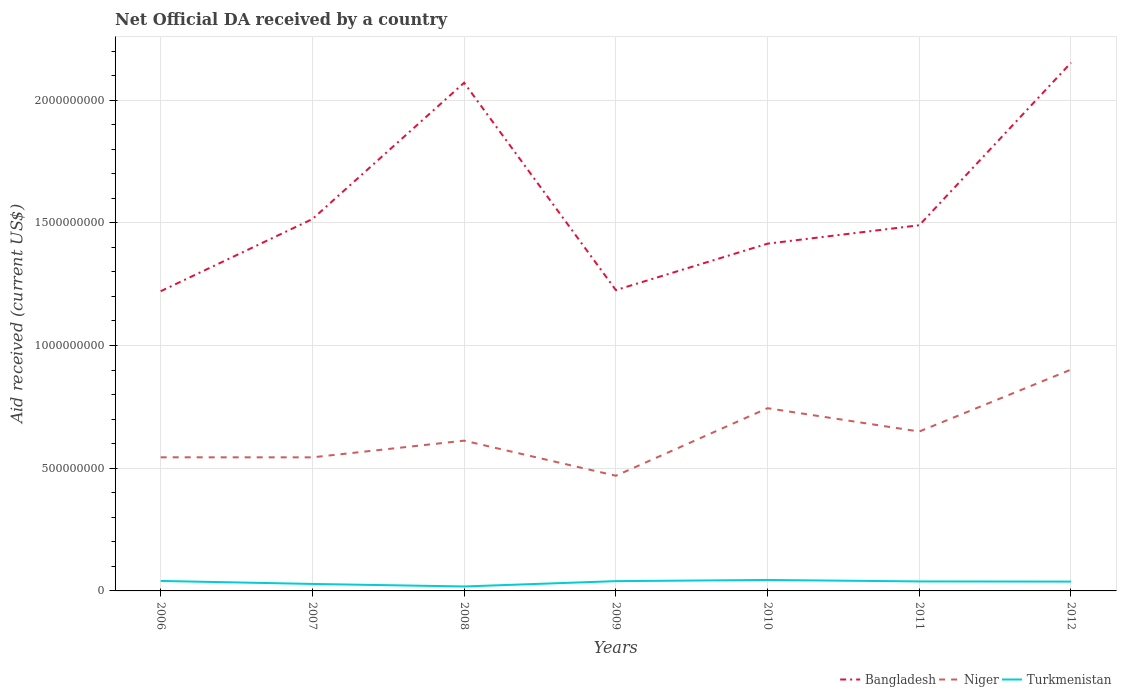Is the number of lines equal to the number of legend labels?
Ensure brevity in your answer.  Yes. Across all years, what is the maximum net official development assistance aid received in Bangladesh?
Offer a terse response. 1.22e+09. In which year was the net official development assistance aid received in Turkmenistan maximum?
Ensure brevity in your answer.  2008. What is the total net official development assistance aid received in Turkmenistan in the graph?
Your answer should be very brief. 5.97e+06. What is the difference between the highest and the second highest net official development assistance aid received in Turkmenistan?
Make the answer very short. 2.65e+07. Is the net official development assistance aid received in Turkmenistan strictly greater than the net official development assistance aid received in Niger over the years?
Offer a terse response. Yes. How many lines are there?
Your response must be concise. 3. What is the difference between two consecutive major ticks on the Y-axis?
Offer a very short reply. 5.00e+08. What is the title of the graph?
Provide a succinct answer. Net Official DA received by a country. Does "Dominica" appear as one of the legend labels in the graph?
Offer a very short reply. No. What is the label or title of the Y-axis?
Your response must be concise. Aid received (current US$). What is the Aid received (current US$) of Bangladesh in 2006?
Provide a succinct answer. 1.22e+09. What is the Aid received (current US$) in Niger in 2006?
Give a very brief answer. 5.44e+08. What is the Aid received (current US$) of Turkmenistan in 2006?
Keep it short and to the point. 4.07e+07. What is the Aid received (current US$) of Bangladesh in 2007?
Your response must be concise. 1.52e+09. What is the Aid received (current US$) of Niger in 2007?
Offer a terse response. 5.44e+08. What is the Aid received (current US$) in Turkmenistan in 2007?
Provide a short and direct response. 2.85e+07. What is the Aid received (current US$) of Bangladesh in 2008?
Keep it short and to the point. 2.07e+09. What is the Aid received (current US$) of Niger in 2008?
Offer a terse response. 6.12e+08. What is the Aid received (current US$) in Turkmenistan in 2008?
Your response must be concise. 1.81e+07. What is the Aid received (current US$) in Bangladesh in 2009?
Keep it short and to the point. 1.23e+09. What is the Aid received (current US$) in Niger in 2009?
Your answer should be compact. 4.69e+08. What is the Aid received (current US$) of Turkmenistan in 2009?
Give a very brief answer. 3.98e+07. What is the Aid received (current US$) in Bangladesh in 2010?
Provide a short and direct response. 1.41e+09. What is the Aid received (current US$) of Niger in 2010?
Provide a succinct answer. 7.45e+08. What is the Aid received (current US$) in Turkmenistan in 2010?
Make the answer very short. 4.46e+07. What is the Aid received (current US$) in Bangladesh in 2011?
Keep it short and to the point. 1.49e+09. What is the Aid received (current US$) in Niger in 2011?
Your response must be concise. 6.50e+08. What is the Aid received (current US$) in Turkmenistan in 2011?
Keep it short and to the point. 3.87e+07. What is the Aid received (current US$) in Bangladesh in 2012?
Provide a succinct answer. 2.15e+09. What is the Aid received (current US$) in Niger in 2012?
Give a very brief answer. 9.02e+08. What is the Aid received (current US$) of Turkmenistan in 2012?
Keep it short and to the point. 3.80e+07. Across all years, what is the maximum Aid received (current US$) of Bangladesh?
Your answer should be very brief. 2.15e+09. Across all years, what is the maximum Aid received (current US$) in Niger?
Your answer should be very brief. 9.02e+08. Across all years, what is the maximum Aid received (current US$) in Turkmenistan?
Your answer should be compact. 4.46e+07. Across all years, what is the minimum Aid received (current US$) of Bangladesh?
Your response must be concise. 1.22e+09. Across all years, what is the minimum Aid received (current US$) of Niger?
Provide a succinct answer. 4.69e+08. Across all years, what is the minimum Aid received (current US$) of Turkmenistan?
Offer a very short reply. 1.81e+07. What is the total Aid received (current US$) of Bangladesh in the graph?
Your answer should be very brief. 1.11e+1. What is the total Aid received (current US$) in Niger in the graph?
Ensure brevity in your answer.  4.47e+09. What is the total Aid received (current US$) in Turkmenistan in the graph?
Your answer should be compact. 2.49e+08. What is the difference between the Aid received (current US$) of Bangladesh in 2006 and that in 2007?
Your answer should be compact. -2.94e+08. What is the difference between the Aid received (current US$) of Niger in 2006 and that in 2007?
Ensure brevity in your answer.  1.10e+05. What is the difference between the Aid received (current US$) in Turkmenistan in 2006 and that in 2007?
Your answer should be very brief. 1.22e+07. What is the difference between the Aid received (current US$) in Bangladesh in 2006 and that in 2008?
Offer a very short reply. -8.49e+08. What is the difference between the Aid received (current US$) in Niger in 2006 and that in 2008?
Offer a terse response. -6.79e+07. What is the difference between the Aid received (current US$) of Turkmenistan in 2006 and that in 2008?
Provide a short and direct response. 2.26e+07. What is the difference between the Aid received (current US$) of Bangladesh in 2006 and that in 2009?
Offer a very short reply. -4.64e+06. What is the difference between the Aid received (current US$) of Niger in 2006 and that in 2009?
Make the answer very short. 7.51e+07. What is the difference between the Aid received (current US$) of Turkmenistan in 2006 and that in 2009?
Make the answer very short. 8.70e+05. What is the difference between the Aid received (current US$) in Bangladesh in 2006 and that in 2010?
Give a very brief answer. -1.94e+08. What is the difference between the Aid received (current US$) of Niger in 2006 and that in 2010?
Offer a very short reply. -2.00e+08. What is the difference between the Aid received (current US$) of Turkmenistan in 2006 and that in 2010?
Give a very brief answer. -3.94e+06. What is the difference between the Aid received (current US$) in Bangladesh in 2006 and that in 2011?
Offer a terse response. -2.69e+08. What is the difference between the Aid received (current US$) in Niger in 2006 and that in 2011?
Keep it short and to the point. -1.05e+08. What is the difference between the Aid received (current US$) in Turkmenistan in 2006 and that in 2011?
Ensure brevity in your answer.  2.03e+06. What is the difference between the Aid received (current US$) in Bangladesh in 2006 and that in 2012?
Keep it short and to the point. -9.31e+08. What is the difference between the Aid received (current US$) in Niger in 2006 and that in 2012?
Your answer should be very brief. -3.57e+08. What is the difference between the Aid received (current US$) of Turkmenistan in 2006 and that in 2012?
Offer a very short reply. 2.68e+06. What is the difference between the Aid received (current US$) of Bangladesh in 2007 and that in 2008?
Ensure brevity in your answer.  -5.55e+08. What is the difference between the Aid received (current US$) in Niger in 2007 and that in 2008?
Make the answer very short. -6.80e+07. What is the difference between the Aid received (current US$) of Turkmenistan in 2007 and that in 2008?
Your answer should be very brief. 1.04e+07. What is the difference between the Aid received (current US$) of Bangladesh in 2007 and that in 2009?
Keep it short and to the point. 2.89e+08. What is the difference between the Aid received (current US$) of Niger in 2007 and that in 2009?
Your response must be concise. 7.50e+07. What is the difference between the Aid received (current US$) of Turkmenistan in 2007 and that in 2009?
Give a very brief answer. -1.14e+07. What is the difference between the Aid received (current US$) in Bangladesh in 2007 and that in 2010?
Make the answer very short. 1.00e+08. What is the difference between the Aid received (current US$) in Niger in 2007 and that in 2010?
Give a very brief answer. -2.00e+08. What is the difference between the Aid received (current US$) of Turkmenistan in 2007 and that in 2010?
Provide a short and direct response. -1.62e+07. What is the difference between the Aid received (current US$) of Bangladesh in 2007 and that in 2011?
Provide a short and direct response. 2.52e+07. What is the difference between the Aid received (current US$) in Niger in 2007 and that in 2011?
Offer a terse response. -1.05e+08. What is the difference between the Aid received (current US$) of Turkmenistan in 2007 and that in 2011?
Keep it short and to the point. -1.02e+07. What is the difference between the Aid received (current US$) of Bangladesh in 2007 and that in 2012?
Provide a succinct answer. -6.37e+08. What is the difference between the Aid received (current US$) of Niger in 2007 and that in 2012?
Your answer should be very brief. -3.58e+08. What is the difference between the Aid received (current US$) of Turkmenistan in 2007 and that in 2012?
Make the answer very short. -9.55e+06. What is the difference between the Aid received (current US$) of Bangladesh in 2008 and that in 2009?
Your answer should be very brief. 8.45e+08. What is the difference between the Aid received (current US$) in Niger in 2008 and that in 2009?
Keep it short and to the point. 1.43e+08. What is the difference between the Aid received (current US$) in Turkmenistan in 2008 and that in 2009?
Provide a succinct answer. -2.17e+07. What is the difference between the Aid received (current US$) in Bangladesh in 2008 and that in 2010?
Keep it short and to the point. 6.56e+08. What is the difference between the Aid received (current US$) of Niger in 2008 and that in 2010?
Offer a very short reply. -1.32e+08. What is the difference between the Aid received (current US$) in Turkmenistan in 2008 and that in 2010?
Ensure brevity in your answer.  -2.65e+07. What is the difference between the Aid received (current US$) in Bangladesh in 2008 and that in 2011?
Offer a very short reply. 5.81e+08. What is the difference between the Aid received (current US$) of Niger in 2008 and that in 2011?
Your answer should be compact. -3.72e+07. What is the difference between the Aid received (current US$) of Turkmenistan in 2008 and that in 2011?
Offer a very short reply. -2.06e+07. What is the difference between the Aid received (current US$) of Bangladesh in 2008 and that in 2012?
Make the answer very short. -8.15e+07. What is the difference between the Aid received (current US$) in Niger in 2008 and that in 2012?
Keep it short and to the point. -2.90e+08. What is the difference between the Aid received (current US$) of Turkmenistan in 2008 and that in 2012?
Offer a very short reply. -1.99e+07. What is the difference between the Aid received (current US$) in Bangladesh in 2009 and that in 2010?
Your answer should be compact. -1.89e+08. What is the difference between the Aid received (current US$) of Niger in 2009 and that in 2010?
Give a very brief answer. -2.75e+08. What is the difference between the Aid received (current US$) in Turkmenistan in 2009 and that in 2010?
Keep it short and to the point. -4.81e+06. What is the difference between the Aid received (current US$) in Bangladesh in 2009 and that in 2011?
Make the answer very short. -2.64e+08. What is the difference between the Aid received (current US$) in Niger in 2009 and that in 2011?
Offer a very short reply. -1.80e+08. What is the difference between the Aid received (current US$) of Turkmenistan in 2009 and that in 2011?
Provide a short and direct response. 1.16e+06. What is the difference between the Aid received (current US$) of Bangladesh in 2009 and that in 2012?
Offer a very short reply. -9.26e+08. What is the difference between the Aid received (current US$) of Niger in 2009 and that in 2012?
Your answer should be compact. -4.33e+08. What is the difference between the Aid received (current US$) in Turkmenistan in 2009 and that in 2012?
Make the answer very short. 1.81e+06. What is the difference between the Aid received (current US$) in Bangladesh in 2010 and that in 2011?
Provide a short and direct response. -7.51e+07. What is the difference between the Aid received (current US$) in Niger in 2010 and that in 2011?
Offer a terse response. 9.50e+07. What is the difference between the Aid received (current US$) in Turkmenistan in 2010 and that in 2011?
Provide a short and direct response. 5.97e+06. What is the difference between the Aid received (current US$) of Bangladesh in 2010 and that in 2012?
Make the answer very short. -7.37e+08. What is the difference between the Aid received (current US$) of Niger in 2010 and that in 2012?
Ensure brevity in your answer.  -1.57e+08. What is the difference between the Aid received (current US$) of Turkmenistan in 2010 and that in 2012?
Keep it short and to the point. 6.62e+06. What is the difference between the Aid received (current US$) in Bangladesh in 2011 and that in 2012?
Your response must be concise. -6.62e+08. What is the difference between the Aid received (current US$) of Niger in 2011 and that in 2012?
Offer a very short reply. -2.52e+08. What is the difference between the Aid received (current US$) of Turkmenistan in 2011 and that in 2012?
Make the answer very short. 6.50e+05. What is the difference between the Aid received (current US$) in Bangladesh in 2006 and the Aid received (current US$) in Niger in 2007?
Provide a succinct answer. 6.77e+08. What is the difference between the Aid received (current US$) of Bangladesh in 2006 and the Aid received (current US$) of Turkmenistan in 2007?
Make the answer very short. 1.19e+09. What is the difference between the Aid received (current US$) in Niger in 2006 and the Aid received (current US$) in Turkmenistan in 2007?
Ensure brevity in your answer.  5.16e+08. What is the difference between the Aid received (current US$) of Bangladesh in 2006 and the Aid received (current US$) of Niger in 2008?
Provide a succinct answer. 6.09e+08. What is the difference between the Aid received (current US$) of Bangladesh in 2006 and the Aid received (current US$) of Turkmenistan in 2008?
Your answer should be compact. 1.20e+09. What is the difference between the Aid received (current US$) of Niger in 2006 and the Aid received (current US$) of Turkmenistan in 2008?
Your response must be concise. 5.26e+08. What is the difference between the Aid received (current US$) in Bangladesh in 2006 and the Aid received (current US$) in Niger in 2009?
Provide a short and direct response. 7.52e+08. What is the difference between the Aid received (current US$) of Bangladesh in 2006 and the Aid received (current US$) of Turkmenistan in 2009?
Make the answer very short. 1.18e+09. What is the difference between the Aid received (current US$) of Niger in 2006 and the Aid received (current US$) of Turkmenistan in 2009?
Provide a short and direct response. 5.05e+08. What is the difference between the Aid received (current US$) of Bangladesh in 2006 and the Aid received (current US$) of Niger in 2010?
Provide a short and direct response. 4.77e+08. What is the difference between the Aid received (current US$) in Bangladesh in 2006 and the Aid received (current US$) in Turkmenistan in 2010?
Keep it short and to the point. 1.18e+09. What is the difference between the Aid received (current US$) of Niger in 2006 and the Aid received (current US$) of Turkmenistan in 2010?
Your response must be concise. 5.00e+08. What is the difference between the Aid received (current US$) of Bangladesh in 2006 and the Aid received (current US$) of Niger in 2011?
Offer a very short reply. 5.72e+08. What is the difference between the Aid received (current US$) in Bangladesh in 2006 and the Aid received (current US$) in Turkmenistan in 2011?
Your answer should be compact. 1.18e+09. What is the difference between the Aid received (current US$) in Niger in 2006 and the Aid received (current US$) in Turkmenistan in 2011?
Provide a short and direct response. 5.06e+08. What is the difference between the Aid received (current US$) in Bangladesh in 2006 and the Aid received (current US$) in Niger in 2012?
Your response must be concise. 3.19e+08. What is the difference between the Aid received (current US$) of Bangladesh in 2006 and the Aid received (current US$) of Turkmenistan in 2012?
Your answer should be compact. 1.18e+09. What is the difference between the Aid received (current US$) in Niger in 2006 and the Aid received (current US$) in Turkmenistan in 2012?
Your answer should be compact. 5.06e+08. What is the difference between the Aid received (current US$) of Bangladesh in 2007 and the Aid received (current US$) of Niger in 2008?
Your answer should be compact. 9.03e+08. What is the difference between the Aid received (current US$) of Bangladesh in 2007 and the Aid received (current US$) of Turkmenistan in 2008?
Your answer should be compact. 1.50e+09. What is the difference between the Aid received (current US$) in Niger in 2007 and the Aid received (current US$) in Turkmenistan in 2008?
Give a very brief answer. 5.26e+08. What is the difference between the Aid received (current US$) of Bangladesh in 2007 and the Aid received (current US$) of Niger in 2009?
Keep it short and to the point. 1.05e+09. What is the difference between the Aid received (current US$) in Bangladesh in 2007 and the Aid received (current US$) in Turkmenistan in 2009?
Offer a terse response. 1.48e+09. What is the difference between the Aid received (current US$) in Niger in 2007 and the Aid received (current US$) in Turkmenistan in 2009?
Keep it short and to the point. 5.04e+08. What is the difference between the Aid received (current US$) in Bangladesh in 2007 and the Aid received (current US$) in Niger in 2010?
Your response must be concise. 7.71e+08. What is the difference between the Aid received (current US$) in Bangladesh in 2007 and the Aid received (current US$) in Turkmenistan in 2010?
Provide a short and direct response. 1.47e+09. What is the difference between the Aid received (current US$) in Niger in 2007 and the Aid received (current US$) in Turkmenistan in 2010?
Keep it short and to the point. 5.00e+08. What is the difference between the Aid received (current US$) of Bangladesh in 2007 and the Aid received (current US$) of Niger in 2011?
Ensure brevity in your answer.  8.66e+08. What is the difference between the Aid received (current US$) in Bangladesh in 2007 and the Aid received (current US$) in Turkmenistan in 2011?
Provide a succinct answer. 1.48e+09. What is the difference between the Aid received (current US$) of Niger in 2007 and the Aid received (current US$) of Turkmenistan in 2011?
Keep it short and to the point. 5.06e+08. What is the difference between the Aid received (current US$) in Bangladesh in 2007 and the Aid received (current US$) in Niger in 2012?
Your response must be concise. 6.13e+08. What is the difference between the Aid received (current US$) in Bangladesh in 2007 and the Aid received (current US$) in Turkmenistan in 2012?
Give a very brief answer. 1.48e+09. What is the difference between the Aid received (current US$) in Niger in 2007 and the Aid received (current US$) in Turkmenistan in 2012?
Your answer should be very brief. 5.06e+08. What is the difference between the Aid received (current US$) in Bangladesh in 2008 and the Aid received (current US$) in Niger in 2009?
Your response must be concise. 1.60e+09. What is the difference between the Aid received (current US$) of Bangladesh in 2008 and the Aid received (current US$) of Turkmenistan in 2009?
Make the answer very short. 2.03e+09. What is the difference between the Aid received (current US$) in Niger in 2008 and the Aid received (current US$) in Turkmenistan in 2009?
Give a very brief answer. 5.72e+08. What is the difference between the Aid received (current US$) of Bangladesh in 2008 and the Aid received (current US$) of Niger in 2010?
Your answer should be very brief. 1.33e+09. What is the difference between the Aid received (current US$) of Bangladesh in 2008 and the Aid received (current US$) of Turkmenistan in 2010?
Offer a terse response. 2.03e+09. What is the difference between the Aid received (current US$) in Niger in 2008 and the Aid received (current US$) in Turkmenistan in 2010?
Your answer should be compact. 5.68e+08. What is the difference between the Aid received (current US$) of Bangladesh in 2008 and the Aid received (current US$) of Niger in 2011?
Give a very brief answer. 1.42e+09. What is the difference between the Aid received (current US$) in Bangladesh in 2008 and the Aid received (current US$) in Turkmenistan in 2011?
Keep it short and to the point. 2.03e+09. What is the difference between the Aid received (current US$) of Niger in 2008 and the Aid received (current US$) of Turkmenistan in 2011?
Your response must be concise. 5.74e+08. What is the difference between the Aid received (current US$) in Bangladesh in 2008 and the Aid received (current US$) in Niger in 2012?
Your answer should be compact. 1.17e+09. What is the difference between the Aid received (current US$) in Bangladesh in 2008 and the Aid received (current US$) in Turkmenistan in 2012?
Offer a very short reply. 2.03e+09. What is the difference between the Aid received (current US$) in Niger in 2008 and the Aid received (current US$) in Turkmenistan in 2012?
Give a very brief answer. 5.74e+08. What is the difference between the Aid received (current US$) in Bangladesh in 2009 and the Aid received (current US$) in Niger in 2010?
Provide a short and direct response. 4.81e+08. What is the difference between the Aid received (current US$) of Bangladesh in 2009 and the Aid received (current US$) of Turkmenistan in 2010?
Your answer should be compact. 1.18e+09. What is the difference between the Aid received (current US$) of Niger in 2009 and the Aid received (current US$) of Turkmenistan in 2010?
Provide a short and direct response. 4.25e+08. What is the difference between the Aid received (current US$) in Bangladesh in 2009 and the Aid received (current US$) in Niger in 2011?
Make the answer very short. 5.76e+08. What is the difference between the Aid received (current US$) of Bangladesh in 2009 and the Aid received (current US$) of Turkmenistan in 2011?
Ensure brevity in your answer.  1.19e+09. What is the difference between the Aid received (current US$) in Niger in 2009 and the Aid received (current US$) in Turkmenistan in 2011?
Offer a very short reply. 4.31e+08. What is the difference between the Aid received (current US$) in Bangladesh in 2009 and the Aid received (current US$) in Niger in 2012?
Your answer should be very brief. 3.24e+08. What is the difference between the Aid received (current US$) in Bangladesh in 2009 and the Aid received (current US$) in Turkmenistan in 2012?
Your answer should be compact. 1.19e+09. What is the difference between the Aid received (current US$) of Niger in 2009 and the Aid received (current US$) of Turkmenistan in 2012?
Give a very brief answer. 4.31e+08. What is the difference between the Aid received (current US$) of Bangladesh in 2010 and the Aid received (current US$) of Niger in 2011?
Provide a short and direct response. 7.65e+08. What is the difference between the Aid received (current US$) of Bangladesh in 2010 and the Aid received (current US$) of Turkmenistan in 2011?
Provide a succinct answer. 1.38e+09. What is the difference between the Aid received (current US$) in Niger in 2010 and the Aid received (current US$) in Turkmenistan in 2011?
Keep it short and to the point. 7.06e+08. What is the difference between the Aid received (current US$) of Bangladesh in 2010 and the Aid received (current US$) of Niger in 2012?
Give a very brief answer. 5.13e+08. What is the difference between the Aid received (current US$) in Bangladesh in 2010 and the Aid received (current US$) in Turkmenistan in 2012?
Your answer should be compact. 1.38e+09. What is the difference between the Aid received (current US$) in Niger in 2010 and the Aid received (current US$) in Turkmenistan in 2012?
Provide a short and direct response. 7.06e+08. What is the difference between the Aid received (current US$) of Bangladesh in 2011 and the Aid received (current US$) of Niger in 2012?
Your response must be concise. 5.88e+08. What is the difference between the Aid received (current US$) of Bangladesh in 2011 and the Aid received (current US$) of Turkmenistan in 2012?
Keep it short and to the point. 1.45e+09. What is the difference between the Aid received (current US$) in Niger in 2011 and the Aid received (current US$) in Turkmenistan in 2012?
Your answer should be very brief. 6.11e+08. What is the average Aid received (current US$) in Bangladesh per year?
Your response must be concise. 1.58e+09. What is the average Aid received (current US$) in Niger per year?
Offer a terse response. 6.38e+08. What is the average Aid received (current US$) in Turkmenistan per year?
Give a very brief answer. 3.55e+07. In the year 2006, what is the difference between the Aid received (current US$) in Bangladesh and Aid received (current US$) in Niger?
Offer a very short reply. 6.77e+08. In the year 2006, what is the difference between the Aid received (current US$) in Bangladesh and Aid received (current US$) in Turkmenistan?
Offer a very short reply. 1.18e+09. In the year 2006, what is the difference between the Aid received (current US$) of Niger and Aid received (current US$) of Turkmenistan?
Give a very brief answer. 5.04e+08. In the year 2007, what is the difference between the Aid received (current US$) of Bangladesh and Aid received (current US$) of Niger?
Provide a succinct answer. 9.71e+08. In the year 2007, what is the difference between the Aid received (current US$) in Bangladesh and Aid received (current US$) in Turkmenistan?
Ensure brevity in your answer.  1.49e+09. In the year 2007, what is the difference between the Aid received (current US$) in Niger and Aid received (current US$) in Turkmenistan?
Make the answer very short. 5.16e+08. In the year 2008, what is the difference between the Aid received (current US$) of Bangladesh and Aid received (current US$) of Niger?
Make the answer very short. 1.46e+09. In the year 2008, what is the difference between the Aid received (current US$) of Bangladesh and Aid received (current US$) of Turkmenistan?
Offer a very short reply. 2.05e+09. In the year 2008, what is the difference between the Aid received (current US$) of Niger and Aid received (current US$) of Turkmenistan?
Offer a very short reply. 5.94e+08. In the year 2009, what is the difference between the Aid received (current US$) of Bangladesh and Aid received (current US$) of Niger?
Provide a short and direct response. 7.57e+08. In the year 2009, what is the difference between the Aid received (current US$) of Bangladesh and Aid received (current US$) of Turkmenistan?
Ensure brevity in your answer.  1.19e+09. In the year 2009, what is the difference between the Aid received (current US$) of Niger and Aid received (current US$) of Turkmenistan?
Make the answer very short. 4.29e+08. In the year 2010, what is the difference between the Aid received (current US$) in Bangladesh and Aid received (current US$) in Niger?
Provide a succinct answer. 6.70e+08. In the year 2010, what is the difference between the Aid received (current US$) of Bangladesh and Aid received (current US$) of Turkmenistan?
Give a very brief answer. 1.37e+09. In the year 2010, what is the difference between the Aid received (current US$) of Niger and Aid received (current US$) of Turkmenistan?
Give a very brief answer. 7.00e+08. In the year 2011, what is the difference between the Aid received (current US$) of Bangladesh and Aid received (current US$) of Niger?
Keep it short and to the point. 8.41e+08. In the year 2011, what is the difference between the Aid received (current US$) of Bangladesh and Aid received (current US$) of Turkmenistan?
Provide a succinct answer. 1.45e+09. In the year 2011, what is the difference between the Aid received (current US$) in Niger and Aid received (current US$) in Turkmenistan?
Give a very brief answer. 6.11e+08. In the year 2012, what is the difference between the Aid received (current US$) of Bangladesh and Aid received (current US$) of Niger?
Your response must be concise. 1.25e+09. In the year 2012, what is the difference between the Aid received (current US$) in Bangladesh and Aid received (current US$) in Turkmenistan?
Your answer should be very brief. 2.11e+09. In the year 2012, what is the difference between the Aid received (current US$) of Niger and Aid received (current US$) of Turkmenistan?
Offer a very short reply. 8.64e+08. What is the ratio of the Aid received (current US$) in Bangladesh in 2006 to that in 2007?
Offer a very short reply. 0.81. What is the ratio of the Aid received (current US$) of Turkmenistan in 2006 to that in 2007?
Provide a succinct answer. 1.43. What is the ratio of the Aid received (current US$) of Bangladesh in 2006 to that in 2008?
Your answer should be compact. 0.59. What is the ratio of the Aid received (current US$) of Niger in 2006 to that in 2008?
Your answer should be very brief. 0.89. What is the ratio of the Aid received (current US$) in Turkmenistan in 2006 to that in 2008?
Offer a very short reply. 2.25. What is the ratio of the Aid received (current US$) of Bangladesh in 2006 to that in 2009?
Your answer should be compact. 1. What is the ratio of the Aid received (current US$) of Niger in 2006 to that in 2009?
Offer a terse response. 1.16. What is the ratio of the Aid received (current US$) of Turkmenistan in 2006 to that in 2009?
Ensure brevity in your answer.  1.02. What is the ratio of the Aid received (current US$) in Bangladesh in 2006 to that in 2010?
Your answer should be very brief. 0.86. What is the ratio of the Aid received (current US$) of Niger in 2006 to that in 2010?
Keep it short and to the point. 0.73. What is the ratio of the Aid received (current US$) of Turkmenistan in 2006 to that in 2010?
Make the answer very short. 0.91. What is the ratio of the Aid received (current US$) of Bangladesh in 2006 to that in 2011?
Offer a terse response. 0.82. What is the ratio of the Aid received (current US$) of Niger in 2006 to that in 2011?
Ensure brevity in your answer.  0.84. What is the ratio of the Aid received (current US$) in Turkmenistan in 2006 to that in 2011?
Provide a short and direct response. 1.05. What is the ratio of the Aid received (current US$) in Bangladesh in 2006 to that in 2012?
Provide a short and direct response. 0.57. What is the ratio of the Aid received (current US$) of Niger in 2006 to that in 2012?
Ensure brevity in your answer.  0.6. What is the ratio of the Aid received (current US$) of Turkmenistan in 2006 to that in 2012?
Provide a short and direct response. 1.07. What is the ratio of the Aid received (current US$) in Bangladesh in 2007 to that in 2008?
Ensure brevity in your answer.  0.73. What is the ratio of the Aid received (current US$) in Niger in 2007 to that in 2008?
Offer a very short reply. 0.89. What is the ratio of the Aid received (current US$) of Turkmenistan in 2007 to that in 2008?
Ensure brevity in your answer.  1.57. What is the ratio of the Aid received (current US$) of Bangladesh in 2007 to that in 2009?
Provide a succinct answer. 1.24. What is the ratio of the Aid received (current US$) in Niger in 2007 to that in 2009?
Ensure brevity in your answer.  1.16. What is the ratio of the Aid received (current US$) of Turkmenistan in 2007 to that in 2009?
Your response must be concise. 0.71. What is the ratio of the Aid received (current US$) of Bangladesh in 2007 to that in 2010?
Offer a terse response. 1.07. What is the ratio of the Aid received (current US$) of Niger in 2007 to that in 2010?
Keep it short and to the point. 0.73. What is the ratio of the Aid received (current US$) in Turkmenistan in 2007 to that in 2010?
Ensure brevity in your answer.  0.64. What is the ratio of the Aid received (current US$) of Bangladesh in 2007 to that in 2011?
Your response must be concise. 1.02. What is the ratio of the Aid received (current US$) of Niger in 2007 to that in 2011?
Provide a short and direct response. 0.84. What is the ratio of the Aid received (current US$) of Turkmenistan in 2007 to that in 2011?
Make the answer very short. 0.74. What is the ratio of the Aid received (current US$) of Bangladesh in 2007 to that in 2012?
Make the answer very short. 0.7. What is the ratio of the Aid received (current US$) in Niger in 2007 to that in 2012?
Your answer should be very brief. 0.6. What is the ratio of the Aid received (current US$) of Turkmenistan in 2007 to that in 2012?
Give a very brief answer. 0.75. What is the ratio of the Aid received (current US$) in Bangladesh in 2008 to that in 2009?
Ensure brevity in your answer.  1.69. What is the ratio of the Aid received (current US$) of Niger in 2008 to that in 2009?
Your answer should be compact. 1.3. What is the ratio of the Aid received (current US$) in Turkmenistan in 2008 to that in 2009?
Give a very brief answer. 0.46. What is the ratio of the Aid received (current US$) in Bangladesh in 2008 to that in 2010?
Your answer should be compact. 1.46. What is the ratio of the Aid received (current US$) in Niger in 2008 to that in 2010?
Offer a very short reply. 0.82. What is the ratio of the Aid received (current US$) in Turkmenistan in 2008 to that in 2010?
Ensure brevity in your answer.  0.41. What is the ratio of the Aid received (current US$) in Bangladesh in 2008 to that in 2011?
Make the answer very short. 1.39. What is the ratio of the Aid received (current US$) in Niger in 2008 to that in 2011?
Make the answer very short. 0.94. What is the ratio of the Aid received (current US$) in Turkmenistan in 2008 to that in 2011?
Make the answer very short. 0.47. What is the ratio of the Aid received (current US$) of Bangladesh in 2008 to that in 2012?
Offer a very short reply. 0.96. What is the ratio of the Aid received (current US$) of Niger in 2008 to that in 2012?
Provide a short and direct response. 0.68. What is the ratio of the Aid received (current US$) of Turkmenistan in 2008 to that in 2012?
Offer a terse response. 0.48. What is the ratio of the Aid received (current US$) in Bangladesh in 2009 to that in 2010?
Your answer should be compact. 0.87. What is the ratio of the Aid received (current US$) of Niger in 2009 to that in 2010?
Provide a short and direct response. 0.63. What is the ratio of the Aid received (current US$) of Turkmenistan in 2009 to that in 2010?
Provide a short and direct response. 0.89. What is the ratio of the Aid received (current US$) in Bangladesh in 2009 to that in 2011?
Provide a short and direct response. 0.82. What is the ratio of the Aid received (current US$) in Niger in 2009 to that in 2011?
Your answer should be very brief. 0.72. What is the ratio of the Aid received (current US$) of Bangladesh in 2009 to that in 2012?
Keep it short and to the point. 0.57. What is the ratio of the Aid received (current US$) in Niger in 2009 to that in 2012?
Ensure brevity in your answer.  0.52. What is the ratio of the Aid received (current US$) in Turkmenistan in 2009 to that in 2012?
Give a very brief answer. 1.05. What is the ratio of the Aid received (current US$) of Bangladesh in 2010 to that in 2011?
Make the answer very short. 0.95. What is the ratio of the Aid received (current US$) in Niger in 2010 to that in 2011?
Ensure brevity in your answer.  1.15. What is the ratio of the Aid received (current US$) in Turkmenistan in 2010 to that in 2011?
Provide a succinct answer. 1.15. What is the ratio of the Aid received (current US$) of Bangladesh in 2010 to that in 2012?
Keep it short and to the point. 0.66. What is the ratio of the Aid received (current US$) of Niger in 2010 to that in 2012?
Your answer should be compact. 0.83. What is the ratio of the Aid received (current US$) in Turkmenistan in 2010 to that in 2012?
Provide a short and direct response. 1.17. What is the ratio of the Aid received (current US$) in Bangladesh in 2011 to that in 2012?
Make the answer very short. 0.69. What is the ratio of the Aid received (current US$) of Niger in 2011 to that in 2012?
Make the answer very short. 0.72. What is the ratio of the Aid received (current US$) of Turkmenistan in 2011 to that in 2012?
Keep it short and to the point. 1.02. What is the difference between the highest and the second highest Aid received (current US$) in Bangladesh?
Make the answer very short. 8.15e+07. What is the difference between the highest and the second highest Aid received (current US$) in Niger?
Ensure brevity in your answer.  1.57e+08. What is the difference between the highest and the second highest Aid received (current US$) of Turkmenistan?
Offer a terse response. 3.94e+06. What is the difference between the highest and the lowest Aid received (current US$) in Bangladesh?
Your answer should be very brief. 9.31e+08. What is the difference between the highest and the lowest Aid received (current US$) of Niger?
Your response must be concise. 4.33e+08. What is the difference between the highest and the lowest Aid received (current US$) of Turkmenistan?
Ensure brevity in your answer.  2.65e+07. 